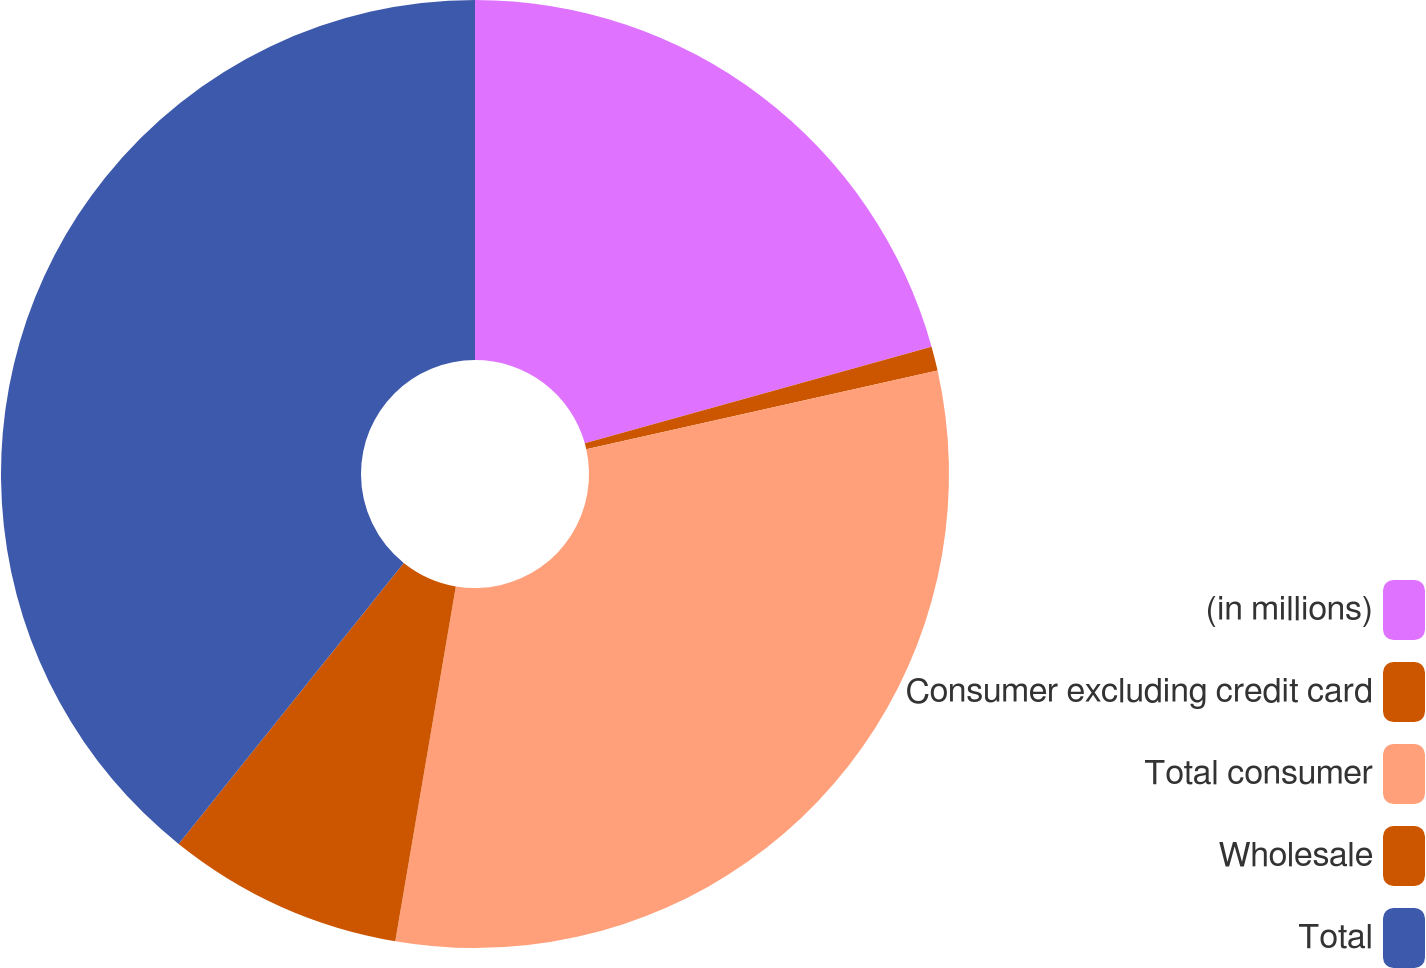<chart> <loc_0><loc_0><loc_500><loc_500><pie_chart><fcel>(in millions)<fcel>Consumer excluding credit card<fcel>Total consumer<fcel>Wholesale<fcel>Total<nl><fcel>20.67%<fcel>0.83%<fcel>31.19%<fcel>8.06%<fcel>39.25%<nl></chart> 